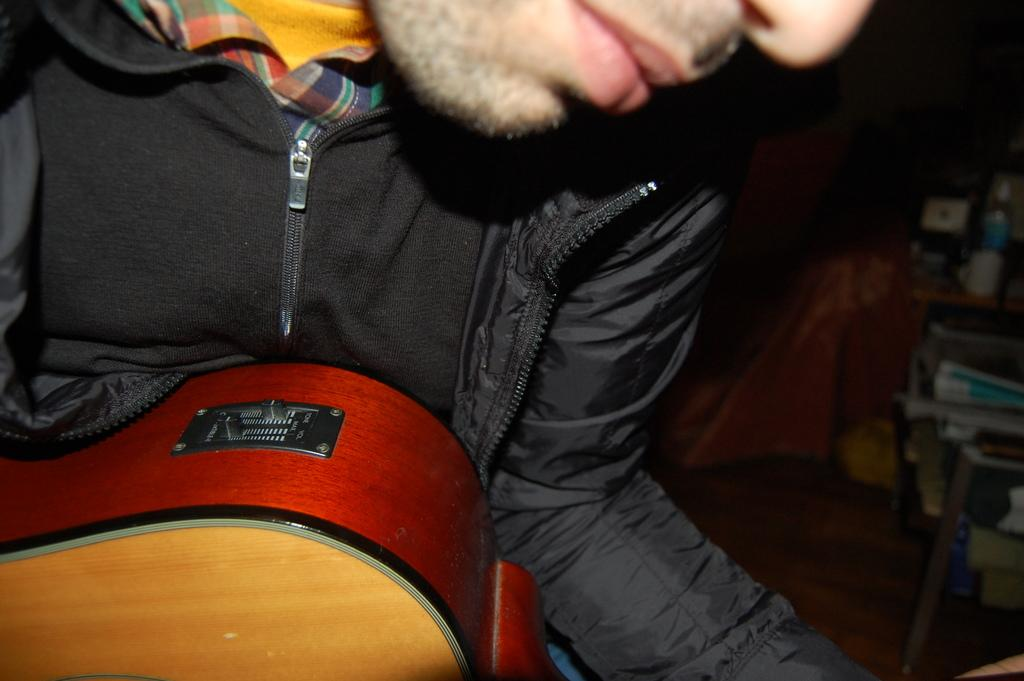What is the main subject of the image? There is a boy in the center of the image. What is the boy holding in the image? The boy is holding a guitar. Can you describe the background of the image? There are objects in the background of the image. What type of glue is the boy using to hold the guitar in the image? There is no glue present in the image, and the boy is holding the guitar with his hands. What kind of coil can be seen wrapped around the boy's legs in the image? There is no coil present in the image, and the boy is standing upright while holding the guitar. 